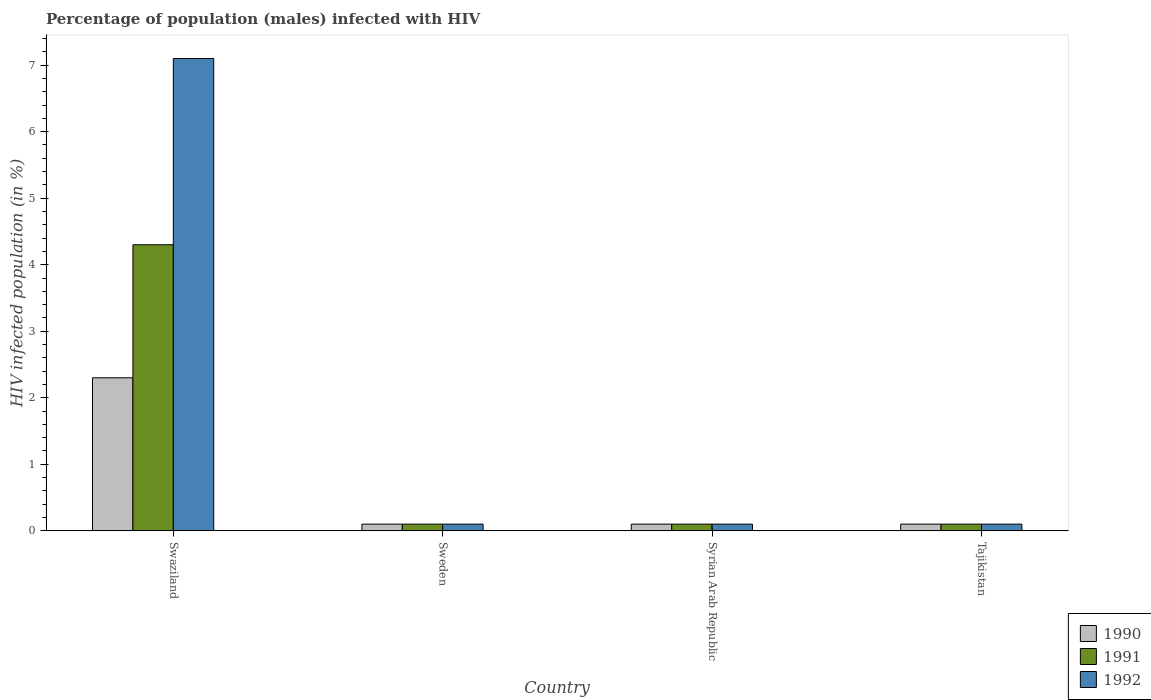How many different coloured bars are there?
Provide a succinct answer. 3. How many bars are there on the 3rd tick from the left?
Provide a succinct answer. 3. What is the label of the 2nd group of bars from the left?
Provide a succinct answer. Sweden. In how many cases, is the number of bars for a given country not equal to the number of legend labels?
Offer a terse response. 0. Across all countries, what is the maximum percentage of HIV infected male population in 1992?
Offer a very short reply. 7.1. In which country was the percentage of HIV infected male population in 1990 maximum?
Your answer should be compact. Swaziland. In which country was the percentage of HIV infected male population in 1992 minimum?
Provide a succinct answer. Sweden. What is the total percentage of HIV infected male population in 1991 in the graph?
Offer a terse response. 4.6. What is the average percentage of HIV infected male population in 1990 per country?
Ensure brevity in your answer.  0.65. What is the difference between the percentage of HIV infected male population of/in 1992 and percentage of HIV infected male population of/in 1991 in Swaziland?
Offer a very short reply. 2.8. In how many countries, is the percentage of HIV infected male population in 1990 greater than 2.6 %?
Ensure brevity in your answer.  0. Is the percentage of HIV infected male population in 1992 in Sweden less than that in Syrian Arab Republic?
Offer a terse response. No. What is the difference between the highest and the second highest percentage of HIV infected male population in 1991?
Your answer should be very brief. -4.2. In how many countries, is the percentage of HIV infected male population in 1990 greater than the average percentage of HIV infected male population in 1990 taken over all countries?
Give a very brief answer. 1. Is the sum of the percentage of HIV infected male population in 1991 in Swaziland and Sweden greater than the maximum percentage of HIV infected male population in 1992 across all countries?
Your answer should be compact. No. What does the 1st bar from the right in Sweden represents?
Keep it short and to the point. 1992. Are all the bars in the graph horizontal?
Provide a succinct answer. No. How many countries are there in the graph?
Provide a short and direct response. 4. Does the graph contain any zero values?
Provide a short and direct response. No. Does the graph contain grids?
Keep it short and to the point. No. Where does the legend appear in the graph?
Offer a terse response. Bottom right. What is the title of the graph?
Your response must be concise. Percentage of population (males) infected with HIV. What is the label or title of the X-axis?
Offer a terse response. Country. What is the label or title of the Y-axis?
Your answer should be compact. HIV infected population (in %). What is the HIV infected population (in %) of 1990 in Swaziland?
Provide a succinct answer. 2.3. What is the HIV infected population (in %) in 1991 in Swaziland?
Your response must be concise. 4.3. What is the HIV infected population (in %) of 1990 in Sweden?
Ensure brevity in your answer.  0.1. What is the HIV infected population (in %) in 1991 in Sweden?
Offer a terse response. 0.1. What is the HIV infected population (in %) in 1990 in Syrian Arab Republic?
Make the answer very short. 0.1. What is the HIV infected population (in %) of 1992 in Syrian Arab Republic?
Provide a short and direct response. 0.1. What is the HIV infected population (in %) of 1990 in Tajikistan?
Make the answer very short. 0.1. Across all countries, what is the maximum HIV infected population (in %) of 1992?
Provide a short and direct response. 7.1. Across all countries, what is the minimum HIV infected population (in %) of 1990?
Offer a very short reply. 0.1. Across all countries, what is the minimum HIV infected population (in %) in 1991?
Provide a short and direct response. 0.1. Across all countries, what is the minimum HIV infected population (in %) in 1992?
Provide a short and direct response. 0.1. What is the total HIV infected population (in %) in 1992 in the graph?
Provide a short and direct response. 7.4. What is the difference between the HIV infected population (in %) of 1991 in Swaziland and that in Syrian Arab Republic?
Your response must be concise. 4.2. What is the difference between the HIV infected population (in %) in 1992 in Swaziland and that in Syrian Arab Republic?
Keep it short and to the point. 7. What is the difference between the HIV infected population (in %) of 1990 in Swaziland and that in Tajikistan?
Keep it short and to the point. 2.2. What is the difference between the HIV infected population (in %) of 1992 in Swaziland and that in Tajikistan?
Keep it short and to the point. 7. What is the difference between the HIV infected population (in %) of 1991 in Sweden and that in Syrian Arab Republic?
Provide a short and direct response. 0. What is the difference between the HIV infected population (in %) in 1992 in Sweden and that in Syrian Arab Republic?
Offer a terse response. 0. What is the difference between the HIV infected population (in %) of 1992 in Sweden and that in Tajikistan?
Provide a succinct answer. 0. What is the difference between the HIV infected population (in %) in 1991 in Syrian Arab Republic and that in Tajikistan?
Give a very brief answer. 0. What is the difference between the HIV infected population (in %) of 1990 in Swaziland and the HIV infected population (in %) of 1992 in Sweden?
Your answer should be very brief. 2.2. What is the difference between the HIV infected population (in %) of 1991 in Swaziland and the HIV infected population (in %) of 1992 in Sweden?
Ensure brevity in your answer.  4.2. What is the difference between the HIV infected population (in %) of 1990 in Swaziland and the HIV infected population (in %) of 1991 in Syrian Arab Republic?
Provide a short and direct response. 2.2. What is the difference between the HIV infected population (in %) of 1991 in Swaziland and the HIV infected population (in %) of 1992 in Syrian Arab Republic?
Make the answer very short. 4.2. What is the difference between the HIV infected population (in %) in 1990 in Swaziland and the HIV infected population (in %) in 1992 in Tajikistan?
Provide a short and direct response. 2.2. What is the difference between the HIV infected population (in %) of 1990 in Sweden and the HIV infected population (in %) of 1991 in Syrian Arab Republic?
Make the answer very short. 0. What is the difference between the HIV infected population (in %) of 1991 in Sweden and the HIV infected population (in %) of 1992 in Syrian Arab Republic?
Provide a short and direct response. 0. What is the difference between the HIV infected population (in %) of 1991 in Sweden and the HIV infected population (in %) of 1992 in Tajikistan?
Offer a terse response. 0. What is the difference between the HIV infected population (in %) of 1990 in Syrian Arab Republic and the HIV infected population (in %) of 1992 in Tajikistan?
Your answer should be very brief. 0. What is the average HIV infected population (in %) in 1990 per country?
Your answer should be very brief. 0.65. What is the average HIV infected population (in %) in 1991 per country?
Your response must be concise. 1.15. What is the average HIV infected population (in %) of 1992 per country?
Give a very brief answer. 1.85. What is the difference between the HIV infected population (in %) of 1990 and HIV infected population (in %) of 1991 in Swaziland?
Make the answer very short. -2. What is the difference between the HIV infected population (in %) in 1990 and HIV infected population (in %) in 1992 in Swaziland?
Provide a short and direct response. -4.8. What is the difference between the HIV infected population (in %) in 1991 and HIV infected population (in %) in 1992 in Swaziland?
Your response must be concise. -2.8. What is the difference between the HIV infected population (in %) in 1990 and HIV infected population (in %) in 1991 in Sweden?
Offer a terse response. 0. What is the difference between the HIV infected population (in %) in 1991 and HIV infected population (in %) in 1992 in Sweden?
Your answer should be very brief. 0. What is the difference between the HIV infected population (in %) in 1990 and HIV infected population (in %) in 1992 in Syrian Arab Republic?
Provide a succinct answer. 0. What is the difference between the HIV infected population (in %) in 1990 and HIV infected population (in %) in 1991 in Tajikistan?
Give a very brief answer. 0. What is the difference between the HIV infected population (in %) in 1990 and HIV infected population (in %) in 1992 in Tajikistan?
Your answer should be very brief. 0. What is the difference between the HIV infected population (in %) of 1991 and HIV infected population (in %) of 1992 in Tajikistan?
Keep it short and to the point. 0. What is the ratio of the HIV infected population (in %) of 1990 in Swaziland to that in Sweden?
Provide a short and direct response. 23. What is the ratio of the HIV infected population (in %) of 1992 in Swaziland to that in Sweden?
Give a very brief answer. 71. What is the ratio of the HIV infected population (in %) of 1990 in Swaziland to that in Syrian Arab Republic?
Ensure brevity in your answer.  23. What is the ratio of the HIV infected population (in %) of 1991 in Swaziland to that in Syrian Arab Republic?
Give a very brief answer. 43. What is the ratio of the HIV infected population (in %) in 1992 in Swaziland to that in Syrian Arab Republic?
Keep it short and to the point. 71. What is the ratio of the HIV infected population (in %) of 1990 in Swaziland to that in Tajikistan?
Ensure brevity in your answer.  23. What is the ratio of the HIV infected population (in %) in 1992 in Swaziland to that in Tajikistan?
Make the answer very short. 71. What is the ratio of the HIV infected population (in %) of 1990 in Sweden to that in Syrian Arab Republic?
Offer a terse response. 1. What is the ratio of the HIV infected population (in %) of 1991 in Sweden to that in Syrian Arab Republic?
Provide a short and direct response. 1. What is the ratio of the HIV infected population (in %) of 1992 in Sweden to that in Syrian Arab Republic?
Your response must be concise. 1. What is the difference between the highest and the second highest HIV infected population (in %) in 1990?
Keep it short and to the point. 2.2. What is the difference between the highest and the second highest HIV infected population (in %) in 1992?
Provide a short and direct response. 7. 